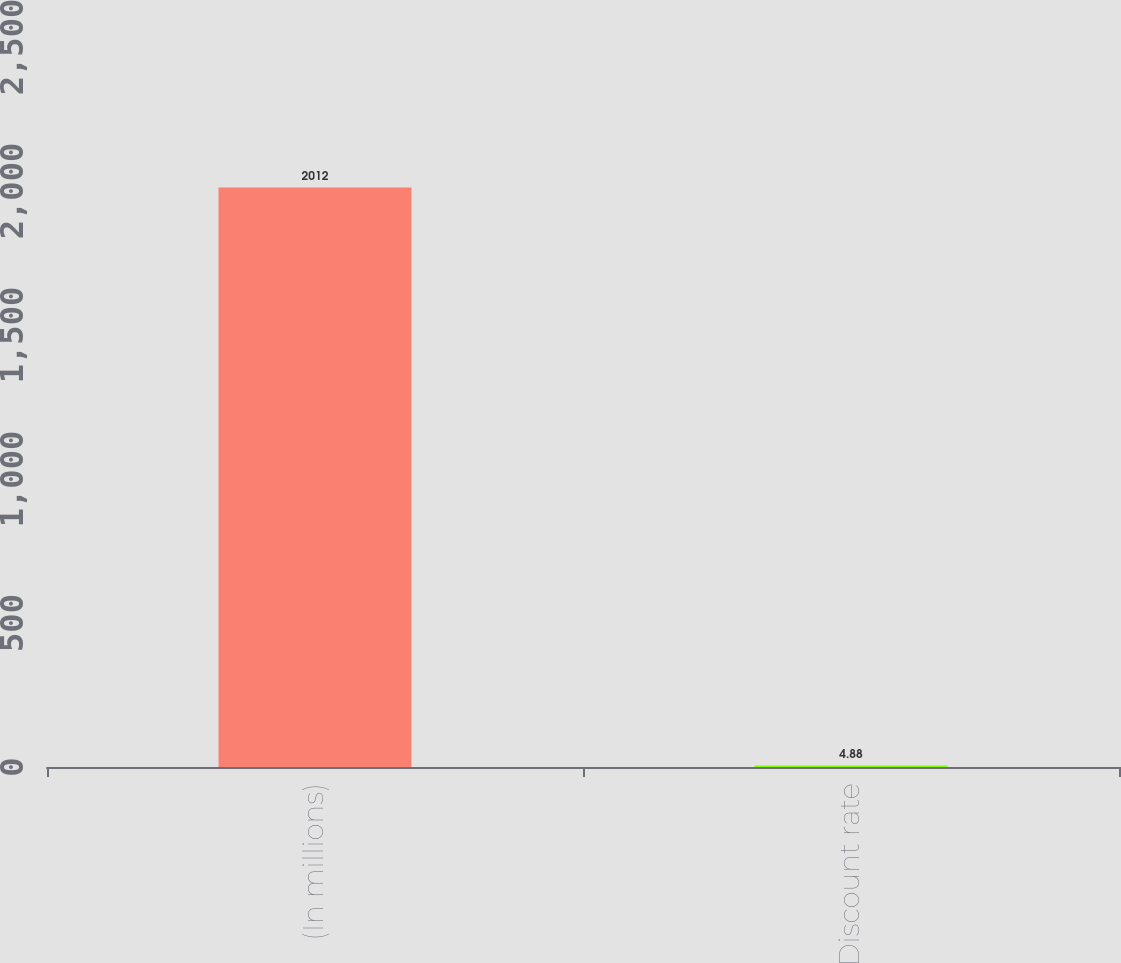Convert chart to OTSL. <chart><loc_0><loc_0><loc_500><loc_500><bar_chart><fcel>(In millions)<fcel>Discount rate<nl><fcel>2012<fcel>4.88<nl></chart> 